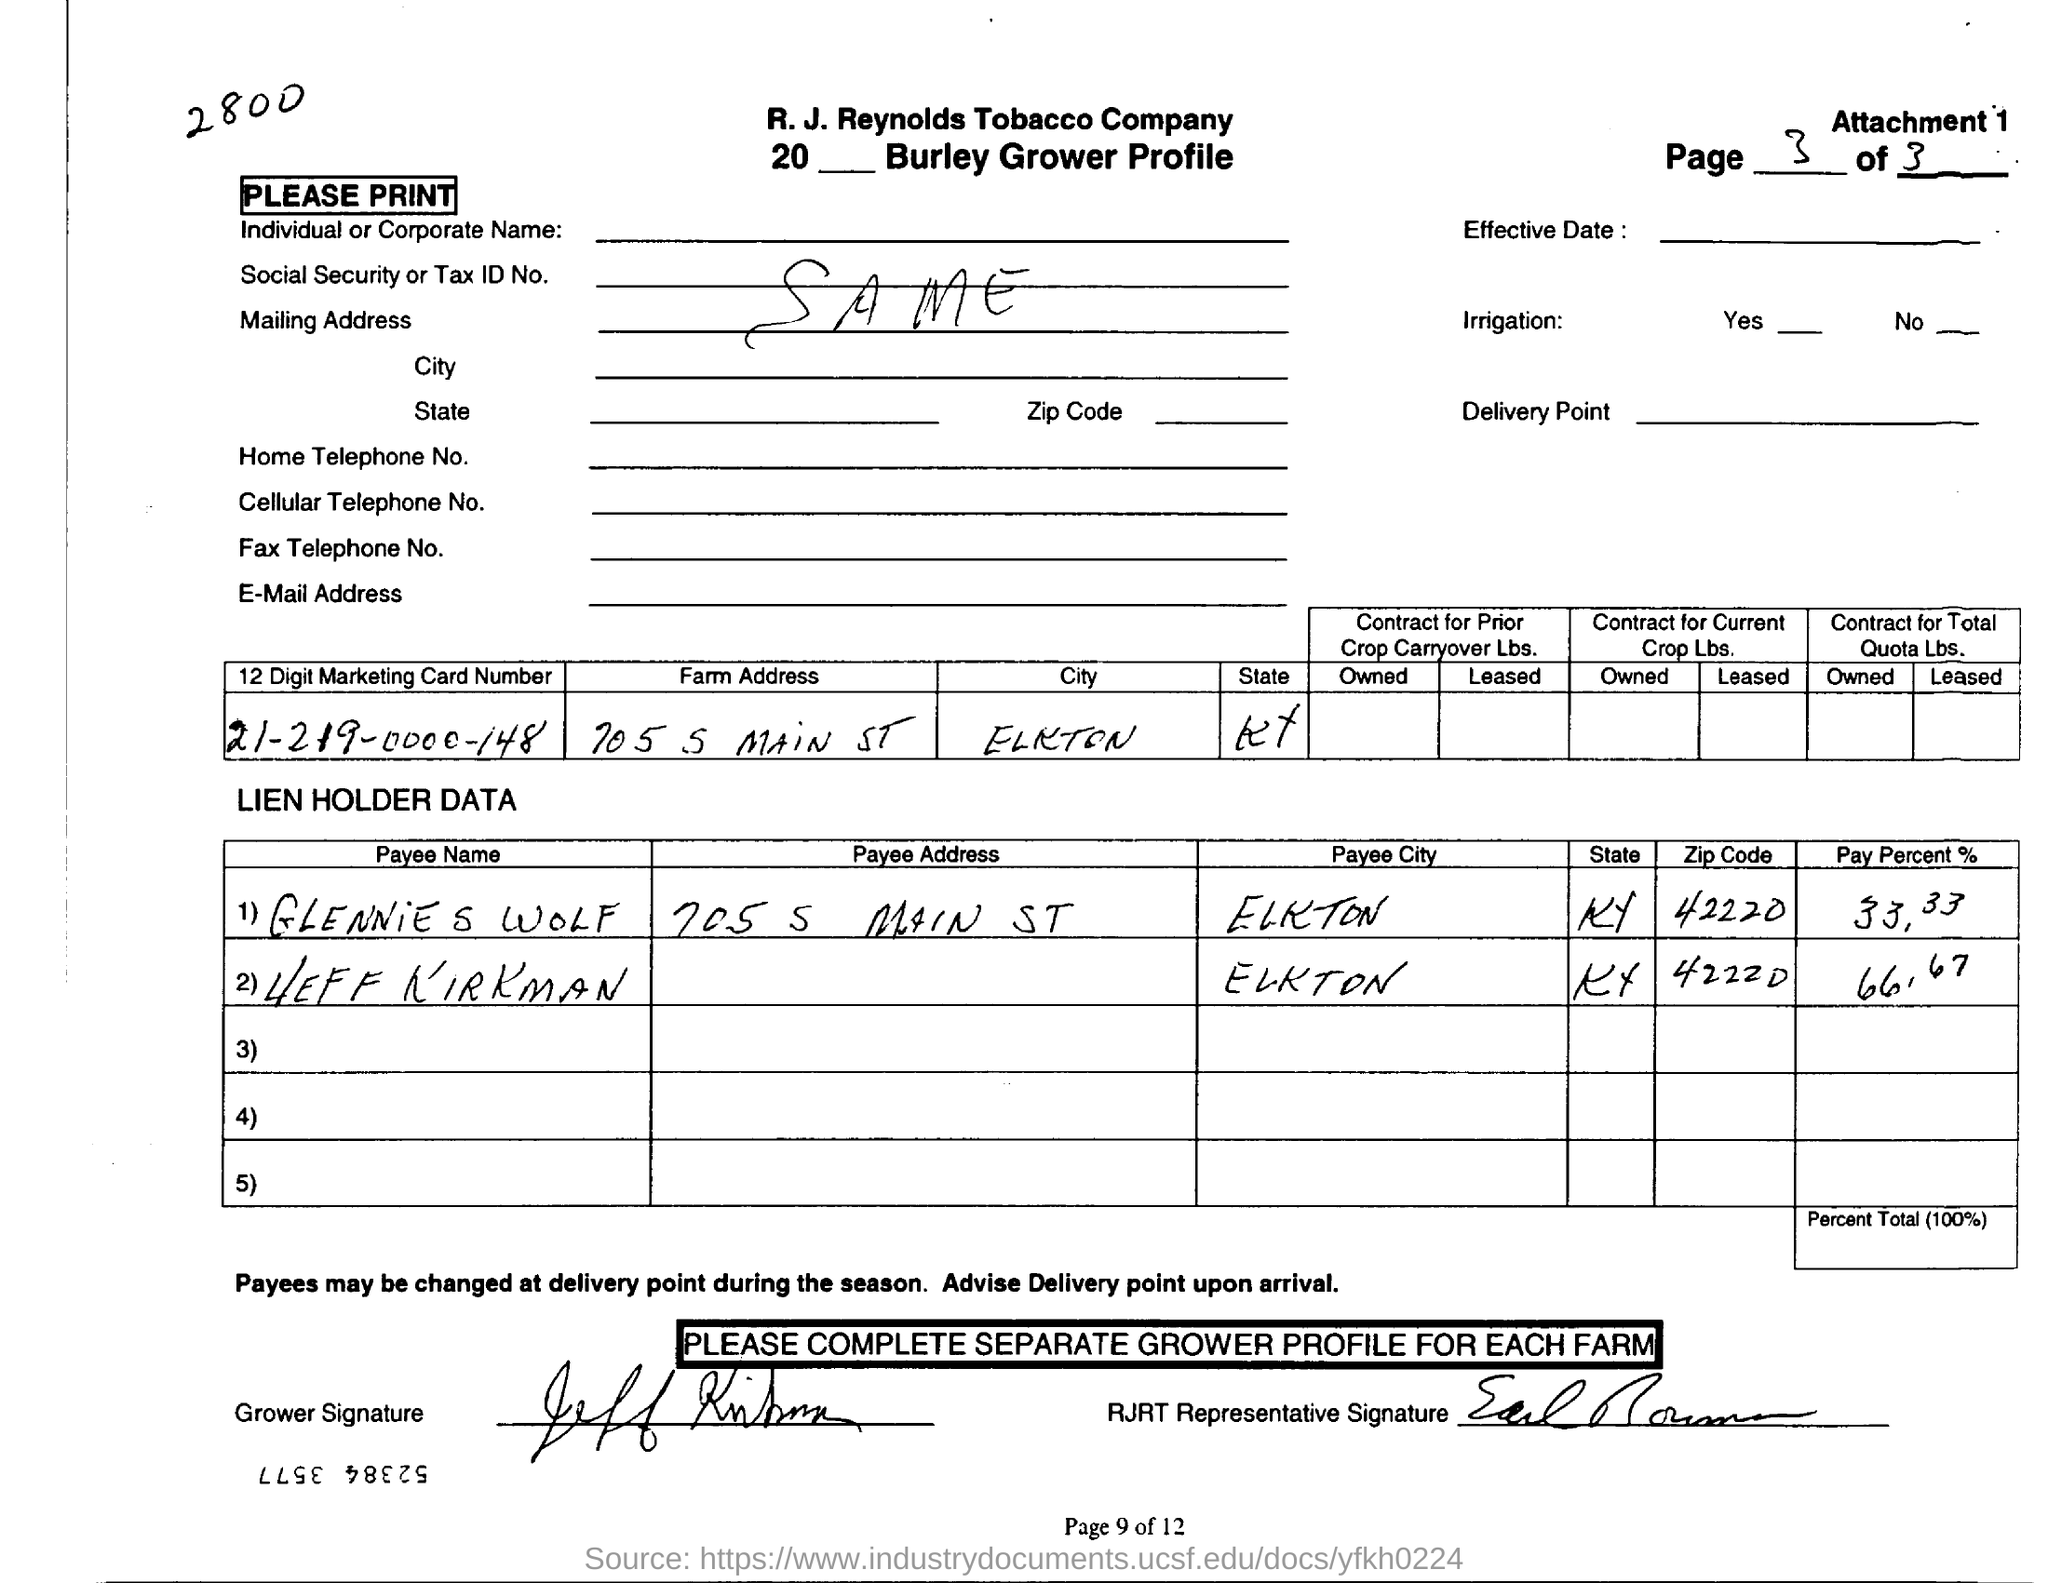Identify some key points in this picture. Your 12-digit marketing card number is 21-219-0000-148. 